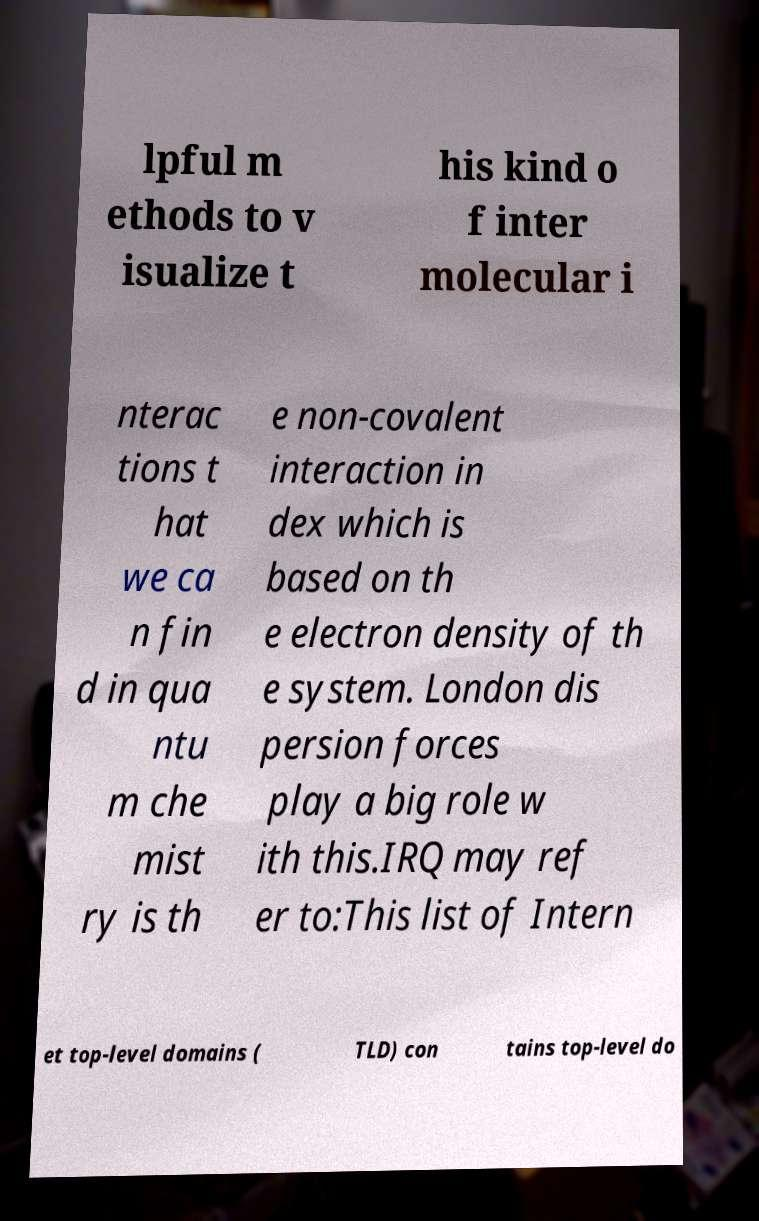Could you assist in decoding the text presented in this image and type it out clearly? lpful m ethods to v isualize t his kind o f inter molecular i nterac tions t hat we ca n fin d in qua ntu m che mist ry is th e non-covalent interaction in dex which is based on th e electron density of th e system. London dis persion forces play a big role w ith this.IRQ may ref er to:This list of Intern et top-level domains ( TLD) con tains top-level do 